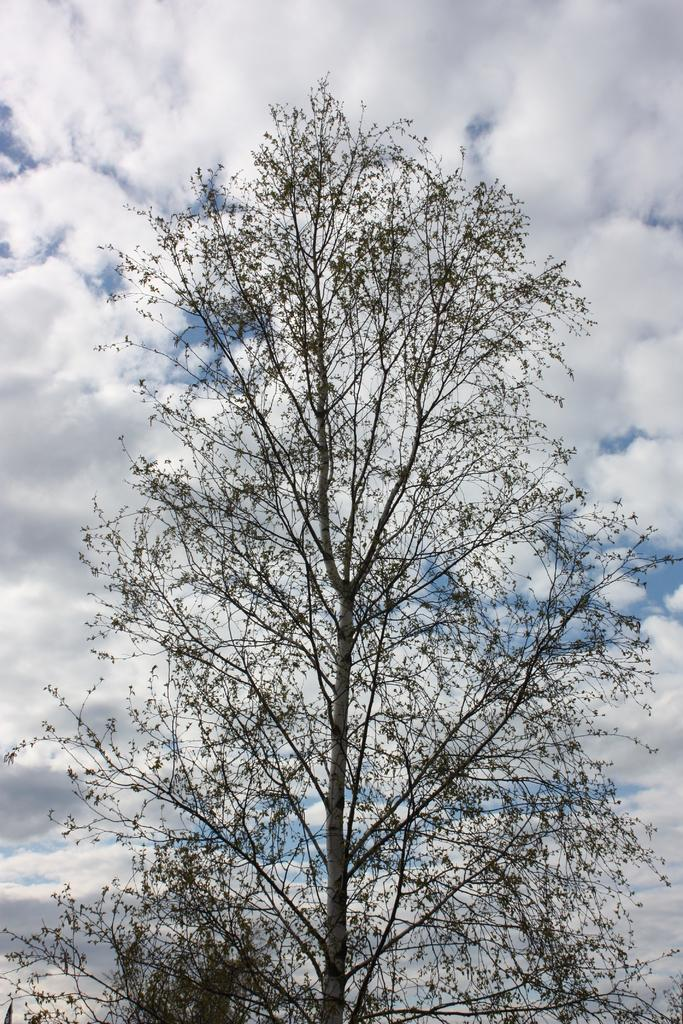What type of vegetation is visible in the front of the image? There are dry trees in the front of the image. What is the condition of the sky in the image? The sky is cloudy in the image. Where is the shelf located in the image? There is no shelf present in the image. What type of test can be seen being conducted in the image? There is no test being conducted in the image. 